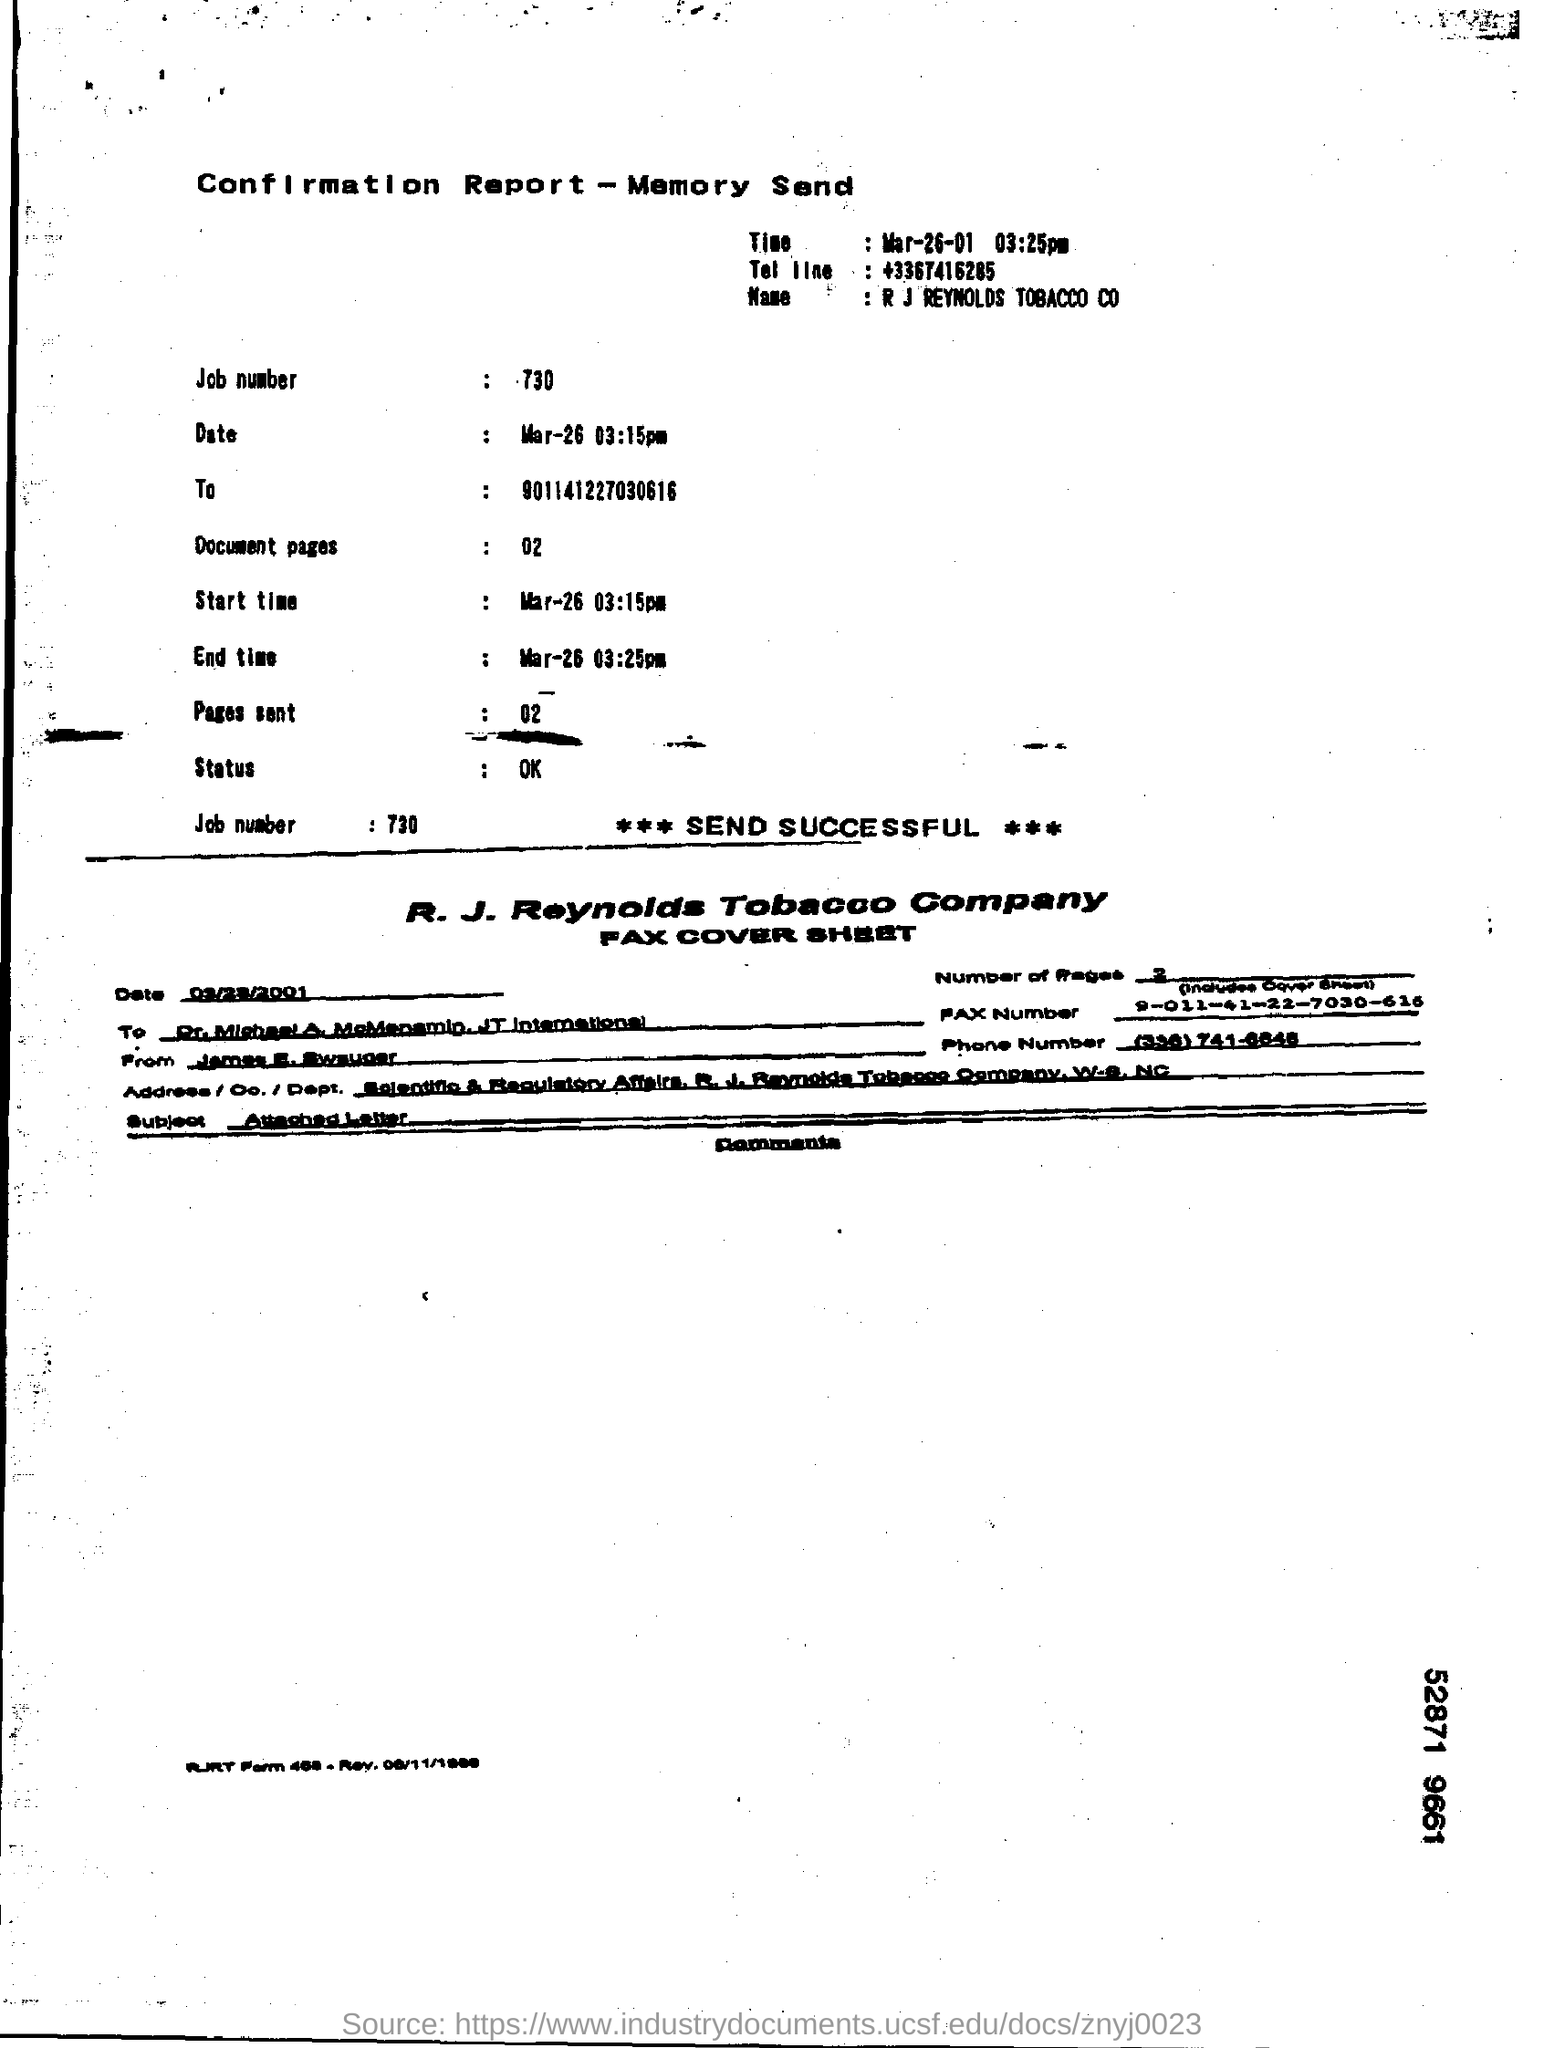Draw attention to some important aspects in this diagram. The job number is 730. The R. J. Reynolds Tobacco Company is named. The phone number mentioned is +3367416285... It is a Confirmation Report that I am inquiring about. 